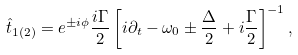Convert formula to latex. <formula><loc_0><loc_0><loc_500><loc_500>\hat { t } _ { 1 ( 2 ) } = e ^ { \pm i \phi } \frac { i \Gamma } 2 \left [ i \partial _ { t } - \omega _ { 0 } \pm \frac { \Delta } { 2 } + i \frac { \Gamma } { 2 } \right ] ^ { - 1 } ,</formula> 